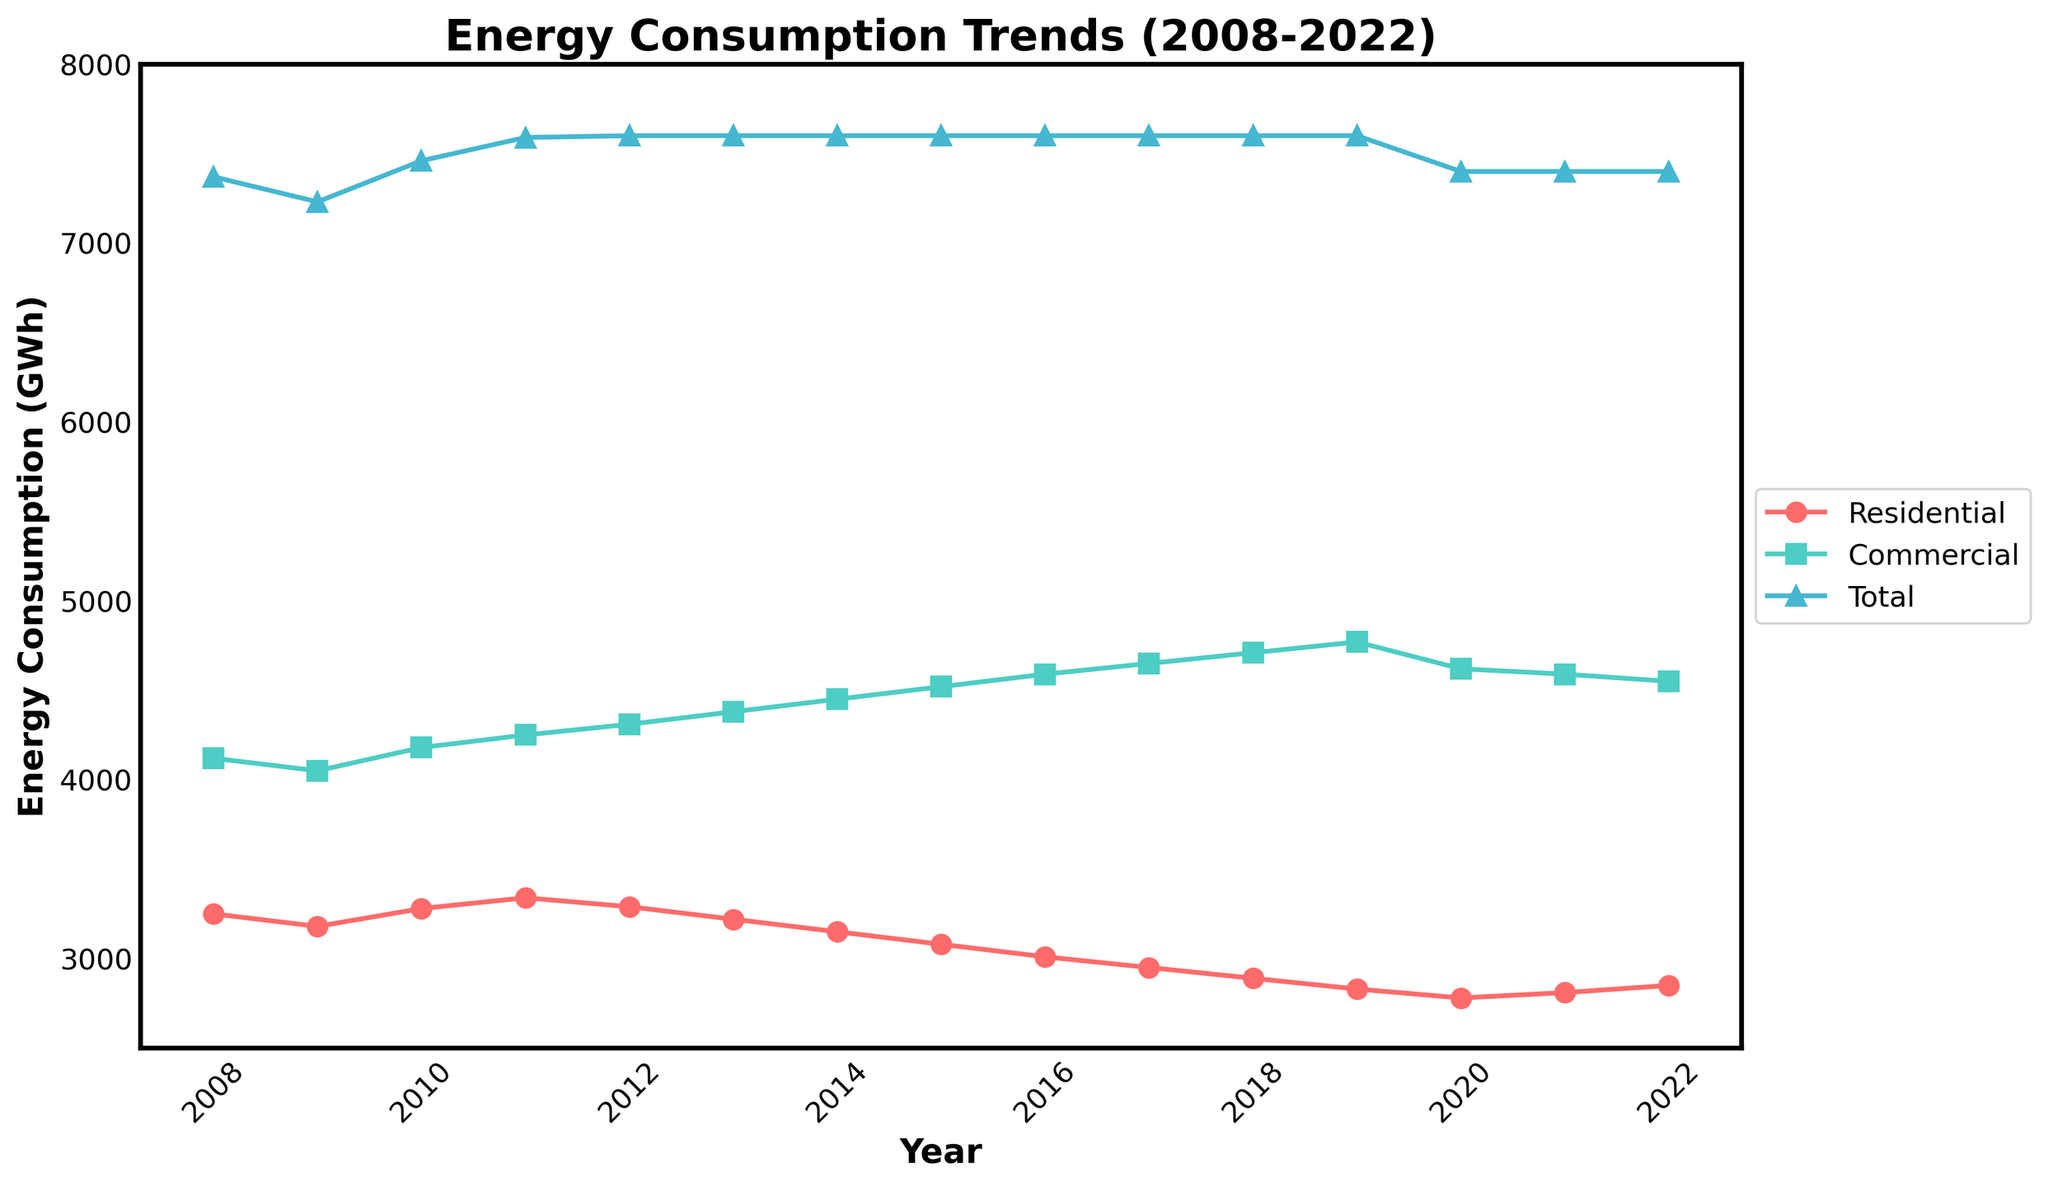What is the overall trend in residential energy consumption from 2008 to 2022? The residential energy consumption shows a general downward trend over the years from 2008 to 2022.
Answer: Downward trend Which year had the highest commercial energy consumption and what was its value? By examining the green line and the peak points, the year with the highest commercial energy consumption is 2019, with a value of 4770 GWh.
Answer: 2019, 4770 GWh Compare the residential and commercial energy consumption in 2015. Which one is higher and by how much? In 2015, the residential energy consumption is 3080 GWh and the commercial energy consumption is 4520 GWh. The commercial energy consumption is higher by 4520 - 3080 = 1440 GWh.
Answer: Commercial is higher by 1440 GWh What was the total energy consumption in 2010 and how does it compare to 2020? The total energy consumption in 2010 was 7460 GWh. In 2020, it was 7400 GWh. Therefore, 2010 had 7460 - 7400 = 60 GWh more total energy consumption compared to 2020.
Answer: 60 GWh more in 2010 In which years did residential energy consumption consistently decrease? From the data and the red line in the plot, the years where residential energy consumption decreased consistently are from 2011 to 2019.
Answer: 2011 to 2019 Is there any year where the total energy consumption was equal? If so, which years? By scrutinizing the blue line, it is observed that from 2012 to 2019, the total energy consumption remained constant at 7600 GWh each year.
Answer: 2012 to 2019 What is the average residential energy consumption over the 15 years? Summing up the residential energy consumption values from 2008 to 2022 and dividing by 15, i.e., (3250+3180+3280+3340+3290+3220+3150+3080+3010+2950+2890+2830+2780+2810+2850)/15 = 3096 GWh.
Answer: 3096 GWh How did the commercial energy consumption change from 2018 to 2020? The commercial energy consumption decreased from 4710 GWh in 2018 to 4620 GWh in 2020, a reduction of 4710 - 4620 = 90 GWh.
Answer: Decreased by 90 GWh What visual elements are used to distinguish between residential and commercial energy consumption on the plot? The residential energy consumption line is depicted in red with circles, while the commercial energy consumption line is shown in green with squares.
Answer: Red circles and green squares 